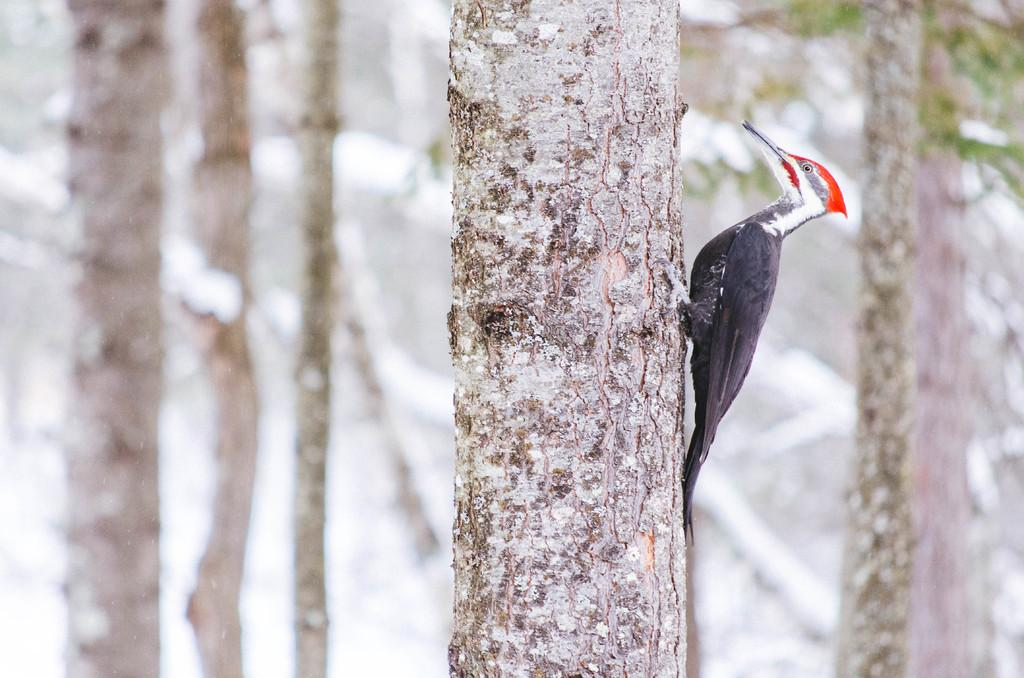What type of animal can be seen in the image? There is a bird in the image. What can be seen in the background of the image? There are trees in the image. Reasoning: Let's think step by identifying the main subjects and objects in the image based on the provided facts. We then formulate questions that focus on the location and characteristics of these subjects and objects, ensuring that each question can be answered definitively with the information given. We avoid yes/no questions and ensure that the language is simple and clear. Absurd Question/Answer: What type of force is being applied to the bird in the image? There is no force being applied to the bird in the image; it is simply perched or flying. Is there a knife visible in the image? No, there is no knife present in the image. What type of day is depicted in the image? The provided facts do not mention any specific day or time of day, so it cannot be determined from the image. 